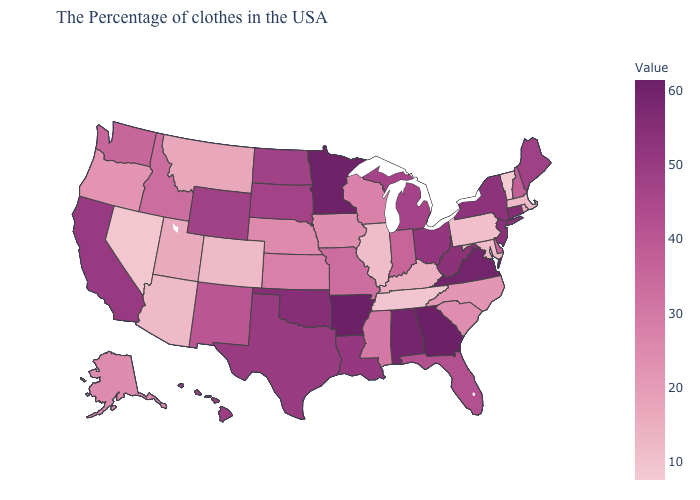Which states have the highest value in the USA?
Give a very brief answer. Arkansas. Among the states that border North Carolina , which have the lowest value?
Short answer required. Tennessee. Does the map have missing data?
Concise answer only. No. Does Colorado have the highest value in the West?
Concise answer only. No. Which states have the lowest value in the USA?
Give a very brief answer. Vermont. Which states have the lowest value in the USA?
Concise answer only. Vermont. 